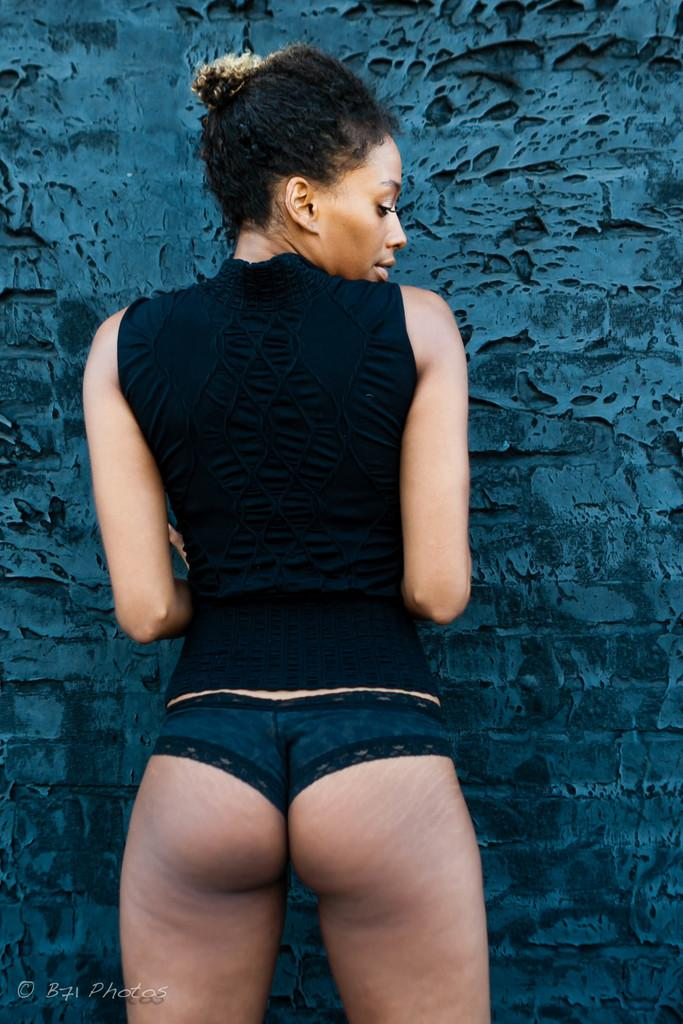Who is the main subject in the image? There is a lady in the image. What is the lady doing in the image? The lady is standing in the image. Which direction is the lady facing? The lady is facing towards a wall in the image. How many beds can be seen in the image? There are no beds present in the image; it features a lady standing and facing a wall. What type of watch is the lady wearing in the image? There is no watch visible on the lady in the image. 